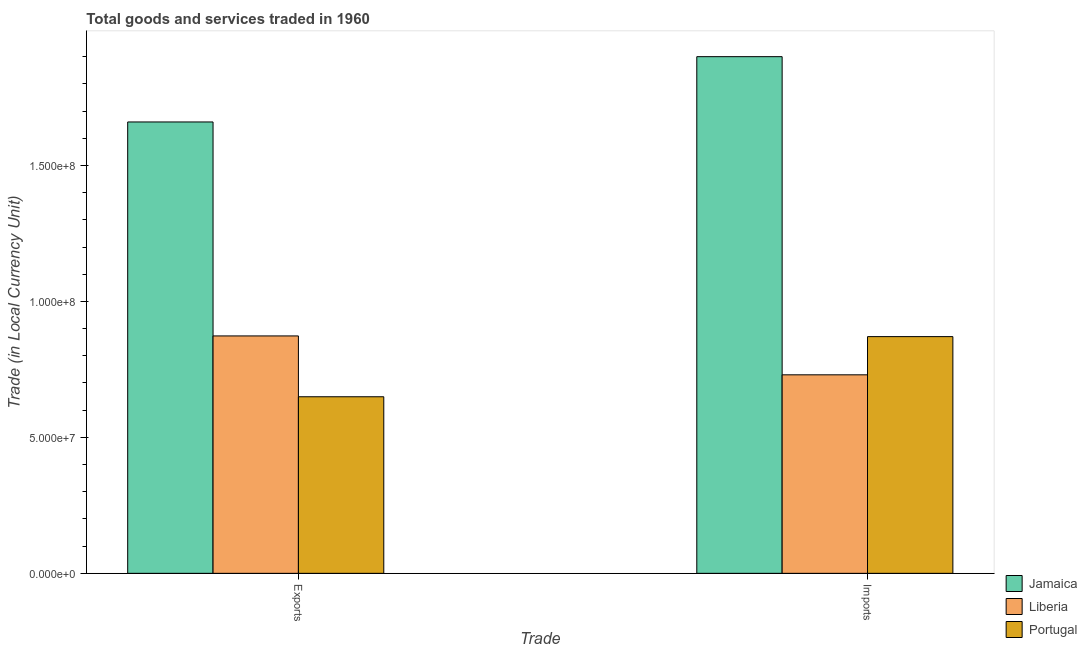Are the number of bars per tick equal to the number of legend labels?
Offer a very short reply. Yes. Are the number of bars on each tick of the X-axis equal?
Your response must be concise. Yes. What is the label of the 2nd group of bars from the left?
Provide a succinct answer. Imports. What is the imports of goods and services in Portugal?
Give a very brief answer. 8.70e+07. Across all countries, what is the maximum imports of goods and services?
Your answer should be very brief. 1.90e+08. Across all countries, what is the minimum export of goods and services?
Give a very brief answer. 6.49e+07. In which country was the imports of goods and services maximum?
Your answer should be compact. Jamaica. In which country was the imports of goods and services minimum?
Provide a short and direct response. Liberia. What is the total export of goods and services in the graph?
Ensure brevity in your answer.  3.18e+08. What is the difference between the export of goods and services in Jamaica and that in Portugal?
Your answer should be compact. 1.01e+08. What is the difference between the export of goods and services in Liberia and the imports of goods and services in Portugal?
Offer a very short reply. 2.52e+05. What is the average export of goods and services per country?
Make the answer very short. 1.06e+08. What is the difference between the export of goods and services and imports of goods and services in Jamaica?
Keep it short and to the point. -2.40e+07. In how many countries, is the imports of goods and services greater than 120000000 LCU?
Provide a succinct answer. 1. What is the ratio of the export of goods and services in Portugal to that in Jamaica?
Your answer should be very brief. 0.39. What does the 2nd bar from the left in Exports represents?
Make the answer very short. Liberia. What does the 2nd bar from the right in Exports represents?
Your answer should be very brief. Liberia. Does the graph contain grids?
Your answer should be compact. No. What is the title of the graph?
Provide a succinct answer. Total goods and services traded in 1960. What is the label or title of the X-axis?
Your answer should be compact. Trade. What is the label or title of the Y-axis?
Your answer should be compact. Trade (in Local Currency Unit). What is the Trade (in Local Currency Unit) in Jamaica in Exports?
Keep it short and to the point. 1.66e+08. What is the Trade (in Local Currency Unit) in Liberia in Exports?
Offer a very short reply. 8.73e+07. What is the Trade (in Local Currency Unit) in Portugal in Exports?
Ensure brevity in your answer.  6.49e+07. What is the Trade (in Local Currency Unit) in Jamaica in Imports?
Provide a succinct answer. 1.90e+08. What is the Trade (in Local Currency Unit) in Liberia in Imports?
Your answer should be compact. 7.30e+07. What is the Trade (in Local Currency Unit) in Portugal in Imports?
Make the answer very short. 8.70e+07. Across all Trade, what is the maximum Trade (in Local Currency Unit) in Jamaica?
Give a very brief answer. 1.90e+08. Across all Trade, what is the maximum Trade (in Local Currency Unit) of Liberia?
Your answer should be very brief. 8.73e+07. Across all Trade, what is the maximum Trade (in Local Currency Unit) in Portugal?
Make the answer very short. 8.70e+07. Across all Trade, what is the minimum Trade (in Local Currency Unit) in Jamaica?
Offer a very short reply. 1.66e+08. Across all Trade, what is the minimum Trade (in Local Currency Unit) in Liberia?
Offer a very short reply. 7.30e+07. Across all Trade, what is the minimum Trade (in Local Currency Unit) of Portugal?
Your answer should be compact. 6.49e+07. What is the total Trade (in Local Currency Unit) in Jamaica in the graph?
Offer a very short reply. 3.56e+08. What is the total Trade (in Local Currency Unit) in Liberia in the graph?
Your response must be concise. 1.60e+08. What is the total Trade (in Local Currency Unit) in Portugal in the graph?
Ensure brevity in your answer.  1.52e+08. What is the difference between the Trade (in Local Currency Unit) in Jamaica in Exports and that in Imports?
Your answer should be very brief. -2.40e+07. What is the difference between the Trade (in Local Currency Unit) in Liberia in Exports and that in Imports?
Make the answer very short. 1.43e+07. What is the difference between the Trade (in Local Currency Unit) of Portugal in Exports and that in Imports?
Offer a terse response. -2.21e+07. What is the difference between the Trade (in Local Currency Unit) of Jamaica in Exports and the Trade (in Local Currency Unit) of Liberia in Imports?
Your answer should be compact. 9.30e+07. What is the difference between the Trade (in Local Currency Unit) of Jamaica in Exports and the Trade (in Local Currency Unit) of Portugal in Imports?
Keep it short and to the point. 7.89e+07. What is the difference between the Trade (in Local Currency Unit) of Liberia in Exports and the Trade (in Local Currency Unit) of Portugal in Imports?
Keep it short and to the point. 2.52e+05. What is the average Trade (in Local Currency Unit) of Jamaica per Trade?
Offer a terse response. 1.78e+08. What is the average Trade (in Local Currency Unit) of Liberia per Trade?
Give a very brief answer. 8.02e+07. What is the average Trade (in Local Currency Unit) of Portugal per Trade?
Offer a very short reply. 7.60e+07. What is the difference between the Trade (in Local Currency Unit) in Jamaica and Trade (in Local Currency Unit) in Liberia in Exports?
Provide a succinct answer. 7.87e+07. What is the difference between the Trade (in Local Currency Unit) of Jamaica and Trade (in Local Currency Unit) of Portugal in Exports?
Offer a very short reply. 1.01e+08. What is the difference between the Trade (in Local Currency Unit) in Liberia and Trade (in Local Currency Unit) in Portugal in Exports?
Provide a short and direct response. 2.24e+07. What is the difference between the Trade (in Local Currency Unit) in Jamaica and Trade (in Local Currency Unit) in Liberia in Imports?
Your answer should be compact. 1.17e+08. What is the difference between the Trade (in Local Currency Unit) of Jamaica and Trade (in Local Currency Unit) of Portugal in Imports?
Your answer should be very brief. 1.03e+08. What is the difference between the Trade (in Local Currency Unit) in Liberia and Trade (in Local Currency Unit) in Portugal in Imports?
Offer a very short reply. -1.40e+07. What is the ratio of the Trade (in Local Currency Unit) in Jamaica in Exports to that in Imports?
Offer a terse response. 0.87. What is the ratio of the Trade (in Local Currency Unit) of Liberia in Exports to that in Imports?
Your answer should be compact. 1.2. What is the ratio of the Trade (in Local Currency Unit) in Portugal in Exports to that in Imports?
Ensure brevity in your answer.  0.75. What is the difference between the highest and the second highest Trade (in Local Currency Unit) in Jamaica?
Your response must be concise. 2.40e+07. What is the difference between the highest and the second highest Trade (in Local Currency Unit) of Liberia?
Provide a short and direct response. 1.43e+07. What is the difference between the highest and the second highest Trade (in Local Currency Unit) of Portugal?
Your answer should be compact. 2.21e+07. What is the difference between the highest and the lowest Trade (in Local Currency Unit) in Jamaica?
Provide a succinct answer. 2.40e+07. What is the difference between the highest and the lowest Trade (in Local Currency Unit) of Liberia?
Offer a very short reply. 1.43e+07. What is the difference between the highest and the lowest Trade (in Local Currency Unit) in Portugal?
Offer a terse response. 2.21e+07. 